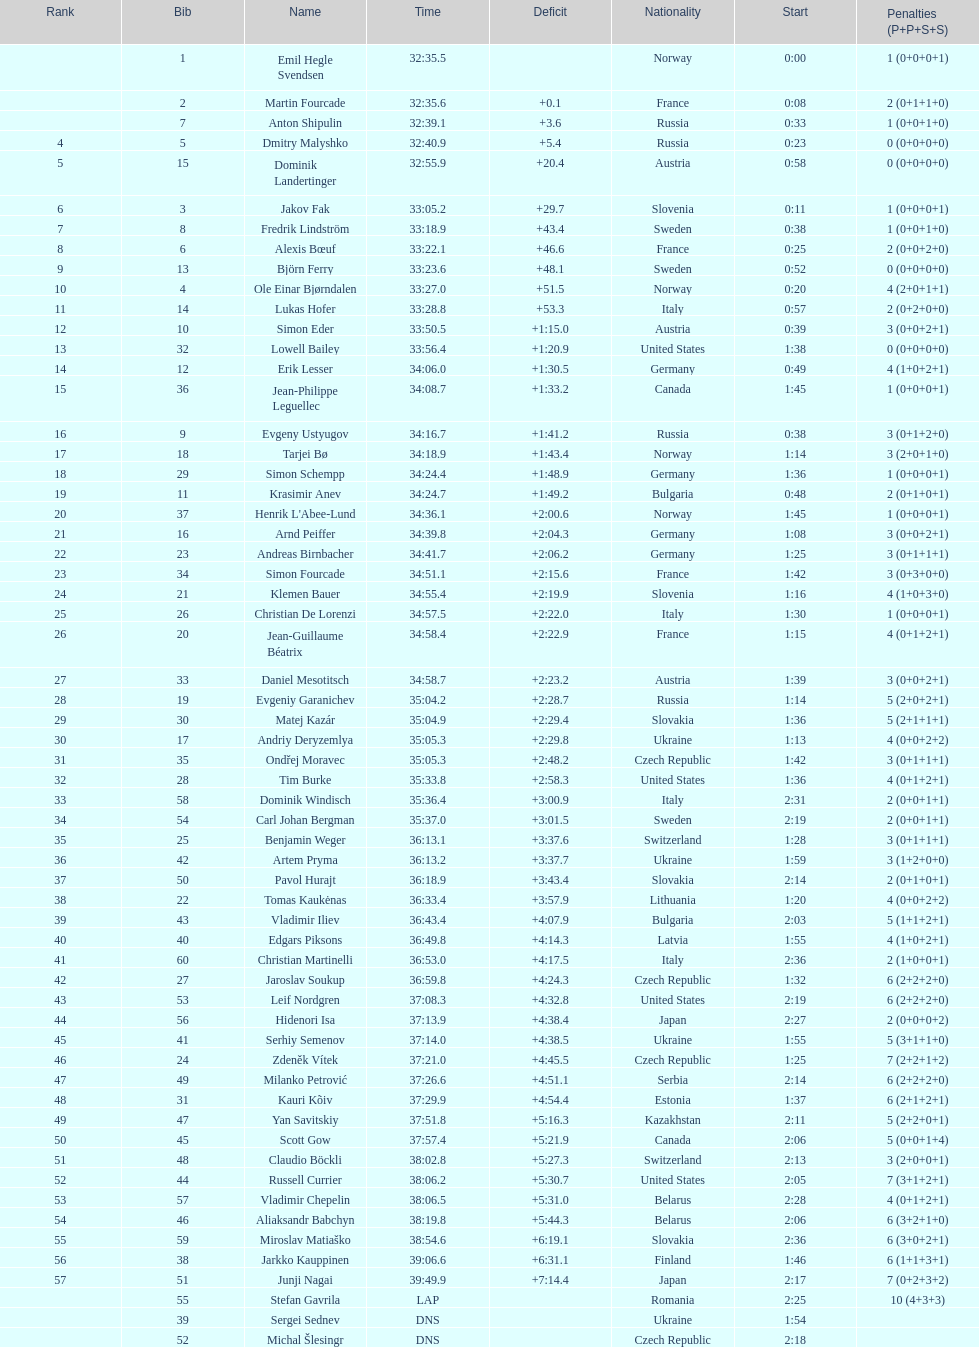Excluding burke, provide the name of a competitor from the united states. Leif Nordgren. 